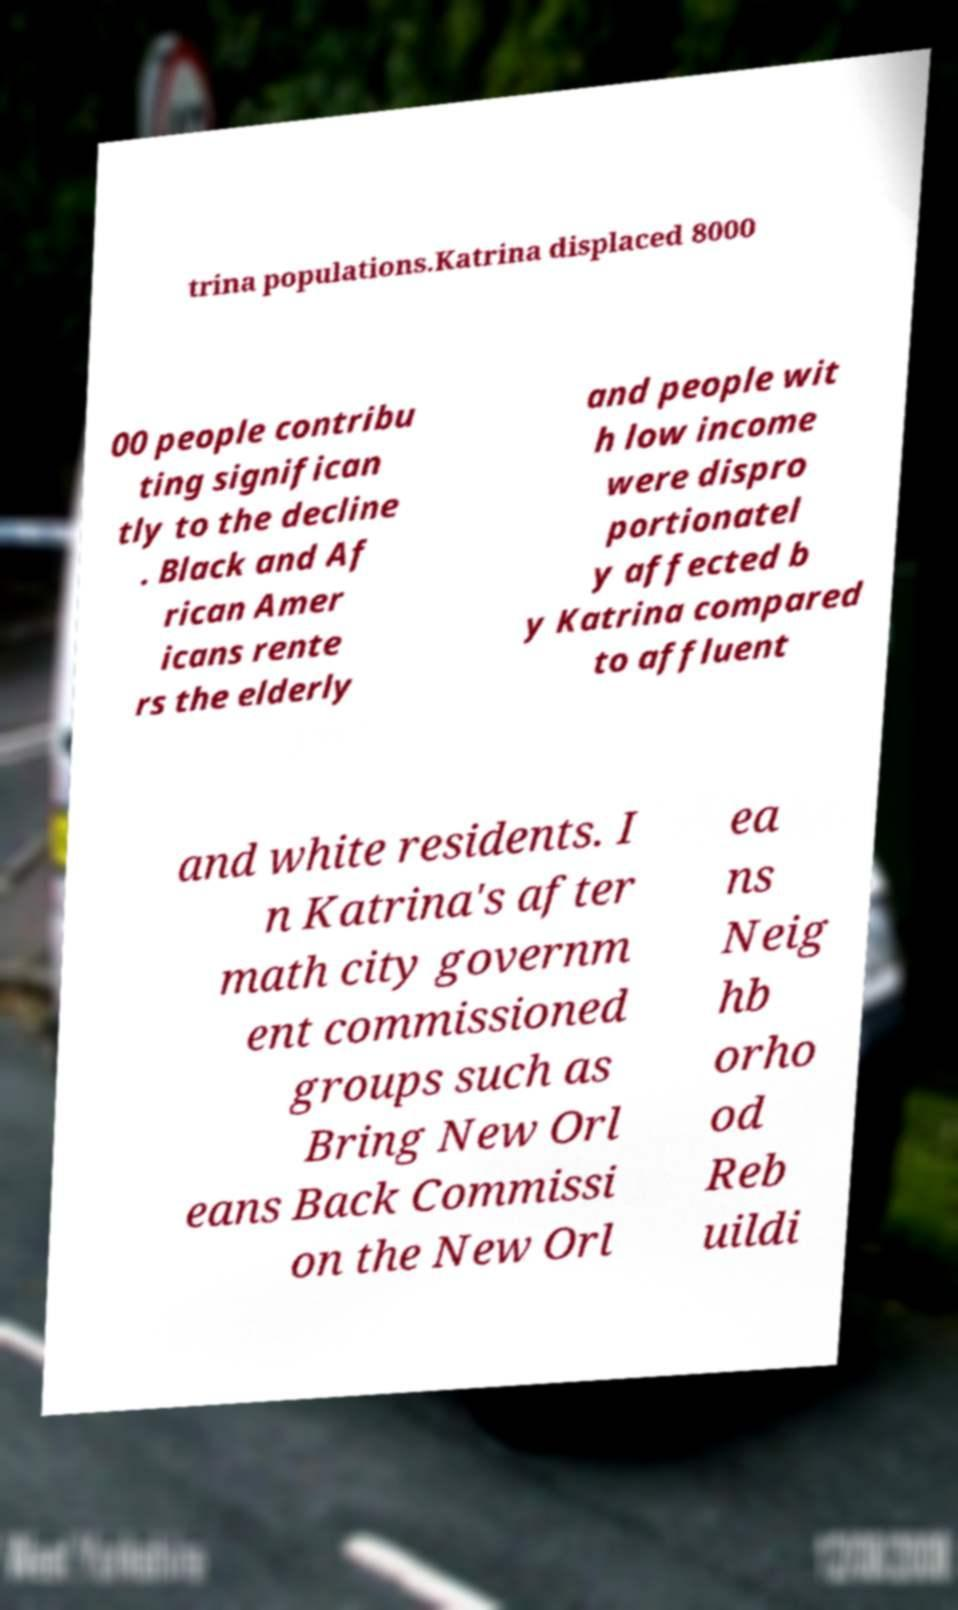Can you read and provide the text displayed in the image?This photo seems to have some interesting text. Can you extract and type it out for me? trina populations.Katrina displaced 8000 00 people contribu ting significan tly to the decline . Black and Af rican Amer icans rente rs the elderly and people wit h low income were dispro portionatel y affected b y Katrina compared to affluent and white residents. I n Katrina's after math city governm ent commissioned groups such as Bring New Orl eans Back Commissi on the New Orl ea ns Neig hb orho od Reb uildi 